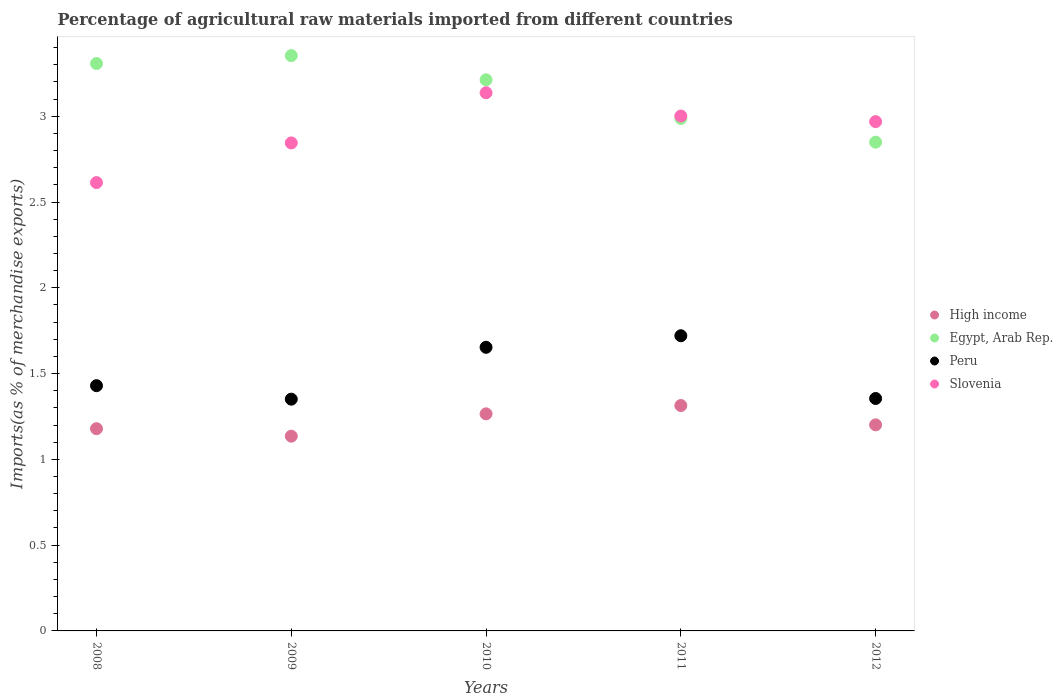What is the percentage of imports to different countries in Slovenia in 2009?
Give a very brief answer. 2.84. Across all years, what is the maximum percentage of imports to different countries in Peru?
Provide a short and direct response. 1.72. Across all years, what is the minimum percentage of imports to different countries in Slovenia?
Make the answer very short. 2.61. In which year was the percentage of imports to different countries in Peru maximum?
Make the answer very short. 2011. In which year was the percentage of imports to different countries in High income minimum?
Ensure brevity in your answer.  2009. What is the total percentage of imports to different countries in High income in the graph?
Offer a very short reply. 6.09. What is the difference between the percentage of imports to different countries in Slovenia in 2009 and that in 2012?
Your answer should be very brief. -0.12. What is the difference between the percentage of imports to different countries in Slovenia in 2009 and the percentage of imports to different countries in Egypt, Arab Rep. in 2010?
Your answer should be very brief. -0.37. What is the average percentage of imports to different countries in Slovenia per year?
Make the answer very short. 2.91. In the year 2010, what is the difference between the percentage of imports to different countries in Slovenia and percentage of imports to different countries in Egypt, Arab Rep.?
Ensure brevity in your answer.  -0.08. In how many years, is the percentage of imports to different countries in Egypt, Arab Rep. greater than 2.4 %?
Keep it short and to the point. 5. What is the ratio of the percentage of imports to different countries in Egypt, Arab Rep. in 2009 to that in 2011?
Provide a short and direct response. 1.12. Is the difference between the percentage of imports to different countries in Slovenia in 2008 and 2009 greater than the difference between the percentage of imports to different countries in Egypt, Arab Rep. in 2008 and 2009?
Your response must be concise. No. What is the difference between the highest and the second highest percentage of imports to different countries in High income?
Your answer should be compact. 0.05. What is the difference between the highest and the lowest percentage of imports to different countries in Egypt, Arab Rep.?
Ensure brevity in your answer.  0.5. In how many years, is the percentage of imports to different countries in Egypt, Arab Rep. greater than the average percentage of imports to different countries in Egypt, Arab Rep. taken over all years?
Keep it short and to the point. 3. Is it the case that in every year, the sum of the percentage of imports to different countries in High income and percentage of imports to different countries in Peru  is greater than the sum of percentage of imports to different countries in Slovenia and percentage of imports to different countries in Egypt, Arab Rep.?
Your answer should be compact. No. Is the percentage of imports to different countries in Slovenia strictly less than the percentage of imports to different countries in Peru over the years?
Your answer should be very brief. No. How many dotlines are there?
Offer a very short reply. 4. How many years are there in the graph?
Make the answer very short. 5. What is the difference between two consecutive major ticks on the Y-axis?
Give a very brief answer. 0.5. Are the values on the major ticks of Y-axis written in scientific E-notation?
Give a very brief answer. No. Does the graph contain grids?
Offer a terse response. No. Where does the legend appear in the graph?
Offer a terse response. Center right. How are the legend labels stacked?
Offer a very short reply. Vertical. What is the title of the graph?
Provide a succinct answer. Percentage of agricultural raw materials imported from different countries. Does "Morocco" appear as one of the legend labels in the graph?
Offer a very short reply. No. What is the label or title of the Y-axis?
Your response must be concise. Imports(as % of merchandise exports). What is the Imports(as % of merchandise exports) of High income in 2008?
Your answer should be compact. 1.18. What is the Imports(as % of merchandise exports) in Egypt, Arab Rep. in 2008?
Offer a terse response. 3.31. What is the Imports(as % of merchandise exports) of Peru in 2008?
Give a very brief answer. 1.43. What is the Imports(as % of merchandise exports) in Slovenia in 2008?
Keep it short and to the point. 2.61. What is the Imports(as % of merchandise exports) in High income in 2009?
Offer a terse response. 1.14. What is the Imports(as % of merchandise exports) in Egypt, Arab Rep. in 2009?
Ensure brevity in your answer.  3.35. What is the Imports(as % of merchandise exports) of Peru in 2009?
Your response must be concise. 1.35. What is the Imports(as % of merchandise exports) in Slovenia in 2009?
Your response must be concise. 2.84. What is the Imports(as % of merchandise exports) in High income in 2010?
Provide a succinct answer. 1.27. What is the Imports(as % of merchandise exports) in Egypt, Arab Rep. in 2010?
Provide a succinct answer. 3.21. What is the Imports(as % of merchandise exports) in Peru in 2010?
Ensure brevity in your answer.  1.65. What is the Imports(as % of merchandise exports) of Slovenia in 2010?
Keep it short and to the point. 3.14. What is the Imports(as % of merchandise exports) in High income in 2011?
Give a very brief answer. 1.31. What is the Imports(as % of merchandise exports) in Egypt, Arab Rep. in 2011?
Your answer should be very brief. 2.99. What is the Imports(as % of merchandise exports) of Peru in 2011?
Offer a very short reply. 1.72. What is the Imports(as % of merchandise exports) of Slovenia in 2011?
Give a very brief answer. 3. What is the Imports(as % of merchandise exports) in High income in 2012?
Provide a succinct answer. 1.2. What is the Imports(as % of merchandise exports) in Egypt, Arab Rep. in 2012?
Ensure brevity in your answer.  2.85. What is the Imports(as % of merchandise exports) of Peru in 2012?
Offer a very short reply. 1.35. What is the Imports(as % of merchandise exports) of Slovenia in 2012?
Offer a very short reply. 2.97. Across all years, what is the maximum Imports(as % of merchandise exports) in High income?
Ensure brevity in your answer.  1.31. Across all years, what is the maximum Imports(as % of merchandise exports) of Egypt, Arab Rep.?
Make the answer very short. 3.35. Across all years, what is the maximum Imports(as % of merchandise exports) in Peru?
Make the answer very short. 1.72. Across all years, what is the maximum Imports(as % of merchandise exports) in Slovenia?
Your answer should be very brief. 3.14. Across all years, what is the minimum Imports(as % of merchandise exports) in High income?
Ensure brevity in your answer.  1.14. Across all years, what is the minimum Imports(as % of merchandise exports) of Egypt, Arab Rep.?
Ensure brevity in your answer.  2.85. Across all years, what is the minimum Imports(as % of merchandise exports) in Peru?
Your answer should be very brief. 1.35. Across all years, what is the minimum Imports(as % of merchandise exports) of Slovenia?
Offer a very short reply. 2.61. What is the total Imports(as % of merchandise exports) of High income in the graph?
Offer a terse response. 6.09. What is the total Imports(as % of merchandise exports) of Egypt, Arab Rep. in the graph?
Your answer should be compact. 15.71. What is the total Imports(as % of merchandise exports) in Peru in the graph?
Give a very brief answer. 7.51. What is the total Imports(as % of merchandise exports) of Slovenia in the graph?
Your answer should be very brief. 14.57. What is the difference between the Imports(as % of merchandise exports) in High income in 2008 and that in 2009?
Offer a terse response. 0.04. What is the difference between the Imports(as % of merchandise exports) in Egypt, Arab Rep. in 2008 and that in 2009?
Your answer should be compact. -0.05. What is the difference between the Imports(as % of merchandise exports) of Peru in 2008 and that in 2009?
Your answer should be very brief. 0.08. What is the difference between the Imports(as % of merchandise exports) of Slovenia in 2008 and that in 2009?
Your answer should be compact. -0.23. What is the difference between the Imports(as % of merchandise exports) in High income in 2008 and that in 2010?
Ensure brevity in your answer.  -0.09. What is the difference between the Imports(as % of merchandise exports) in Egypt, Arab Rep. in 2008 and that in 2010?
Your answer should be compact. 0.09. What is the difference between the Imports(as % of merchandise exports) in Peru in 2008 and that in 2010?
Keep it short and to the point. -0.22. What is the difference between the Imports(as % of merchandise exports) of Slovenia in 2008 and that in 2010?
Make the answer very short. -0.52. What is the difference between the Imports(as % of merchandise exports) of High income in 2008 and that in 2011?
Give a very brief answer. -0.14. What is the difference between the Imports(as % of merchandise exports) in Egypt, Arab Rep. in 2008 and that in 2011?
Keep it short and to the point. 0.32. What is the difference between the Imports(as % of merchandise exports) of Peru in 2008 and that in 2011?
Provide a short and direct response. -0.29. What is the difference between the Imports(as % of merchandise exports) in Slovenia in 2008 and that in 2011?
Provide a short and direct response. -0.39. What is the difference between the Imports(as % of merchandise exports) in High income in 2008 and that in 2012?
Offer a terse response. -0.02. What is the difference between the Imports(as % of merchandise exports) of Egypt, Arab Rep. in 2008 and that in 2012?
Make the answer very short. 0.46. What is the difference between the Imports(as % of merchandise exports) of Peru in 2008 and that in 2012?
Make the answer very short. 0.07. What is the difference between the Imports(as % of merchandise exports) in Slovenia in 2008 and that in 2012?
Provide a short and direct response. -0.36. What is the difference between the Imports(as % of merchandise exports) in High income in 2009 and that in 2010?
Your answer should be compact. -0.13. What is the difference between the Imports(as % of merchandise exports) of Egypt, Arab Rep. in 2009 and that in 2010?
Make the answer very short. 0.14. What is the difference between the Imports(as % of merchandise exports) in Peru in 2009 and that in 2010?
Make the answer very short. -0.3. What is the difference between the Imports(as % of merchandise exports) in Slovenia in 2009 and that in 2010?
Give a very brief answer. -0.29. What is the difference between the Imports(as % of merchandise exports) of High income in 2009 and that in 2011?
Offer a terse response. -0.18. What is the difference between the Imports(as % of merchandise exports) in Egypt, Arab Rep. in 2009 and that in 2011?
Your answer should be very brief. 0.37. What is the difference between the Imports(as % of merchandise exports) in Peru in 2009 and that in 2011?
Provide a short and direct response. -0.37. What is the difference between the Imports(as % of merchandise exports) of Slovenia in 2009 and that in 2011?
Keep it short and to the point. -0.16. What is the difference between the Imports(as % of merchandise exports) in High income in 2009 and that in 2012?
Your response must be concise. -0.07. What is the difference between the Imports(as % of merchandise exports) of Egypt, Arab Rep. in 2009 and that in 2012?
Make the answer very short. 0.5. What is the difference between the Imports(as % of merchandise exports) in Peru in 2009 and that in 2012?
Your response must be concise. -0. What is the difference between the Imports(as % of merchandise exports) in Slovenia in 2009 and that in 2012?
Keep it short and to the point. -0.12. What is the difference between the Imports(as % of merchandise exports) in High income in 2010 and that in 2011?
Give a very brief answer. -0.05. What is the difference between the Imports(as % of merchandise exports) in Egypt, Arab Rep. in 2010 and that in 2011?
Make the answer very short. 0.23. What is the difference between the Imports(as % of merchandise exports) in Peru in 2010 and that in 2011?
Offer a very short reply. -0.07. What is the difference between the Imports(as % of merchandise exports) of Slovenia in 2010 and that in 2011?
Make the answer very short. 0.14. What is the difference between the Imports(as % of merchandise exports) of High income in 2010 and that in 2012?
Provide a succinct answer. 0.06. What is the difference between the Imports(as % of merchandise exports) in Egypt, Arab Rep. in 2010 and that in 2012?
Your response must be concise. 0.36. What is the difference between the Imports(as % of merchandise exports) in Peru in 2010 and that in 2012?
Your response must be concise. 0.3. What is the difference between the Imports(as % of merchandise exports) of Slovenia in 2010 and that in 2012?
Keep it short and to the point. 0.17. What is the difference between the Imports(as % of merchandise exports) in High income in 2011 and that in 2012?
Provide a succinct answer. 0.11. What is the difference between the Imports(as % of merchandise exports) in Egypt, Arab Rep. in 2011 and that in 2012?
Give a very brief answer. 0.14. What is the difference between the Imports(as % of merchandise exports) in Peru in 2011 and that in 2012?
Provide a short and direct response. 0.37. What is the difference between the Imports(as % of merchandise exports) in Slovenia in 2011 and that in 2012?
Offer a very short reply. 0.03. What is the difference between the Imports(as % of merchandise exports) of High income in 2008 and the Imports(as % of merchandise exports) of Egypt, Arab Rep. in 2009?
Provide a succinct answer. -2.17. What is the difference between the Imports(as % of merchandise exports) of High income in 2008 and the Imports(as % of merchandise exports) of Peru in 2009?
Your response must be concise. -0.17. What is the difference between the Imports(as % of merchandise exports) in High income in 2008 and the Imports(as % of merchandise exports) in Slovenia in 2009?
Offer a terse response. -1.67. What is the difference between the Imports(as % of merchandise exports) of Egypt, Arab Rep. in 2008 and the Imports(as % of merchandise exports) of Peru in 2009?
Ensure brevity in your answer.  1.96. What is the difference between the Imports(as % of merchandise exports) in Egypt, Arab Rep. in 2008 and the Imports(as % of merchandise exports) in Slovenia in 2009?
Your answer should be compact. 0.46. What is the difference between the Imports(as % of merchandise exports) of Peru in 2008 and the Imports(as % of merchandise exports) of Slovenia in 2009?
Offer a very short reply. -1.42. What is the difference between the Imports(as % of merchandise exports) in High income in 2008 and the Imports(as % of merchandise exports) in Egypt, Arab Rep. in 2010?
Provide a short and direct response. -2.03. What is the difference between the Imports(as % of merchandise exports) in High income in 2008 and the Imports(as % of merchandise exports) in Peru in 2010?
Keep it short and to the point. -0.47. What is the difference between the Imports(as % of merchandise exports) in High income in 2008 and the Imports(as % of merchandise exports) in Slovenia in 2010?
Ensure brevity in your answer.  -1.96. What is the difference between the Imports(as % of merchandise exports) in Egypt, Arab Rep. in 2008 and the Imports(as % of merchandise exports) in Peru in 2010?
Provide a short and direct response. 1.65. What is the difference between the Imports(as % of merchandise exports) of Egypt, Arab Rep. in 2008 and the Imports(as % of merchandise exports) of Slovenia in 2010?
Ensure brevity in your answer.  0.17. What is the difference between the Imports(as % of merchandise exports) of Peru in 2008 and the Imports(as % of merchandise exports) of Slovenia in 2010?
Your response must be concise. -1.71. What is the difference between the Imports(as % of merchandise exports) in High income in 2008 and the Imports(as % of merchandise exports) in Egypt, Arab Rep. in 2011?
Offer a very short reply. -1.81. What is the difference between the Imports(as % of merchandise exports) of High income in 2008 and the Imports(as % of merchandise exports) of Peru in 2011?
Provide a short and direct response. -0.54. What is the difference between the Imports(as % of merchandise exports) of High income in 2008 and the Imports(as % of merchandise exports) of Slovenia in 2011?
Your response must be concise. -1.82. What is the difference between the Imports(as % of merchandise exports) of Egypt, Arab Rep. in 2008 and the Imports(as % of merchandise exports) of Peru in 2011?
Your answer should be compact. 1.59. What is the difference between the Imports(as % of merchandise exports) of Egypt, Arab Rep. in 2008 and the Imports(as % of merchandise exports) of Slovenia in 2011?
Provide a succinct answer. 0.31. What is the difference between the Imports(as % of merchandise exports) of Peru in 2008 and the Imports(as % of merchandise exports) of Slovenia in 2011?
Keep it short and to the point. -1.57. What is the difference between the Imports(as % of merchandise exports) in High income in 2008 and the Imports(as % of merchandise exports) in Egypt, Arab Rep. in 2012?
Make the answer very short. -1.67. What is the difference between the Imports(as % of merchandise exports) in High income in 2008 and the Imports(as % of merchandise exports) in Peru in 2012?
Ensure brevity in your answer.  -0.18. What is the difference between the Imports(as % of merchandise exports) of High income in 2008 and the Imports(as % of merchandise exports) of Slovenia in 2012?
Provide a short and direct response. -1.79. What is the difference between the Imports(as % of merchandise exports) of Egypt, Arab Rep. in 2008 and the Imports(as % of merchandise exports) of Peru in 2012?
Your answer should be very brief. 1.95. What is the difference between the Imports(as % of merchandise exports) in Egypt, Arab Rep. in 2008 and the Imports(as % of merchandise exports) in Slovenia in 2012?
Your response must be concise. 0.34. What is the difference between the Imports(as % of merchandise exports) of Peru in 2008 and the Imports(as % of merchandise exports) of Slovenia in 2012?
Keep it short and to the point. -1.54. What is the difference between the Imports(as % of merchandise exports) of High income in 2009 and the Imports(as % of merchandise exports) of Egypt, Arab Rep. in 2010?
Offer a very short reply. -2.08. What is the difference between the Imports(as % of merchandise exports) in High income in 2009 and the Imports(as % of merchandise exports) in Peru in 2010?
Ensure brevity in your answer.  -0.52. What is the difference between the Imports(as % of merchandise exports) of High income in 2009 and the Imports(as % of merchandise exports) of Slovenia in 2010?
Give a very brief answer. -2. What is the difference between the Imports(as % of merchandise exports) in Egypt, Arab Rep. in 2009 and the Imports(as % of merchandise exports) in Peru in 2010?
Your response must be concise. 1.7. What is the difference between the Imports(as % of merchandise exports) in Egypt, Arab Rep. in 2009 and the Imports(as % of merchandise exports) in Slovenia in 2010?
Ensure brevity in your answer.  0.22. What is the difference between the Imports(as % of merchandise exports) of Peru in 2009 and the Imports(as % of merchandise exports) of Slovenia in 2010?
Give a very brief answer. -1.79. What is the difference between the Imports(as % of merchandise exports) of High income in 2009 and the Imports(as % of merchandise exports) of Egypt, Arab Rep. in 2011?
Offer a very short reply. -1.85. What is the difference between the Imports(as % of merchandise exports) of High income in 2009 and the Imports(as % of merchandise exports) of Peru in 2011?
Keep it short and to the point. -0.59. What is the difference between the Imports(as % of merchandise exports) in High income in 2009 and the Imports(as % of merchandise exports) in Slovenia in 2011?
Your response must be concise. -1.87. What is the difference between the Imports(as % of merchandise exports) in Egypt, Arab Rep. in 2009 and the Imports(as % of merchandise exports) in Peru in 2011?
Keep it short and to the point. 1.63. What is the difference between the Imports(as % of merchandise exports) of Egypt, Arab Rep. in 2009 and the Imports(as % of merchandise exports) of Slovenia in 2011?
Keep it short and to the point. 0.35. What is the difference between the Imports(as % of merchandise exports) in Peru in 2009 and the Imports(as % of merchandise exports) in Slovenia in 2011?
Provide a short and direct response. -1.65. What is the difference between the Imports(as % of merchandise exports) of High income in 2009 and the Imports(as % of merchandise exports) of Egypt, Arab Rep. in 2012?
Ensure brevity in your answer.  -1.71. What is the difference between the Imports(as % of merchandise exports) in High income in 2009 and the Imports(as % of merchandise exports) in Peru in 2012?
Your answer should be compact. -0.22. What is the difference between the Imports(as % of merchandise exports) of High income in 2009 and the Imports(as % of merchandise exports) of Slovenia in 2012?
Offer a terse response. -1.83. What is the difference between the Imports(as % of merchandise exports) in Egypt, Arab Rep. in 2009 and the Imports(as % of merchandise exports) in Peru in 2012?
Give a very brief answer. 2. What is the difference between the Imports(as % of merchandise exports) of Egypt, Arab Rep. in 2009 and the Imports(as % of merchandise exports) of Slovenia in 2012?
Provide a short and direct response. 0.38. What is the difference between the Imports(as % of merchandise exports) of Peru in 2009 and the Imports(as % of merchandise exports) of Slovenia in 2012?
Provide a succinct answer. -1.62. What is the difference between the Imports(as % of merchandise exports) in High income in 2010 and the Imports(as % of merchandise exports) in Egypt, Arab Rep. in 2011?
Provide a succinct answer. -1.72. What is the difference between the Imports(as % of merchandise exports) of High income in 2010 and the Imports(as % of merchandise exports) of Peru in 2011?
Offer a very short reply. -0.46. What is the difference between the Imports(as % of merchandise exports) in High income in 2010 and the Imports(as % of merchandise exports) in Slovenia in 2011?
Offer a terse response. -1.74. What is the difference between the Imports(as % of merchandise exports) of Egypt, Arab Rep. in 2010 and the Imports(as % of merchandise exports) of Peru in 2011?
Make the answer very short. 1.49. What is the difference between the Imports(as % of merchandise exports) in Egypt, Arab Rep. in 2010 and the Imports(as % of merchandise exports) in Slovenia in 2011?
Offer a very short reply. 0.21. What is the difference between the Imports(as % of merchandise exports) of Peru in 2010 and the Imports(as % of merchandise exports) of Slovenia in 2011?
Ensure brevity in your answer.  -1.35. What is the difference between the Imports(as % of merchandise exports) of High income in 2010 and the Imports(as % of merchandise exports) of Egypt, Arab Rep. in 2012?
Your answer should be compact. -1.58. What is the difference between the Imports(as % of merchandise exports) of High income in 2010 and the Imports(as % of merchandise exports) of Peru in 2012?
Your answer should be very brief. -0.09. What is the difference between the Imports(as % of merchandise exports) in High income in 2010 and the Imports(as % of merchandise exports) in Slovenia in 2012?
Offer a very short reply. -1.7. What is the difference between the Imports(as % of merchandise exports) in Egypt, Arab Rep. in 2010 and the Imports(as % of merchandise exports) in Peru in 2012?
Keep it short and to the point. 1.86. What is the difference between the Imports(as % of merchandise exports) in Egypt, Arab Rep. in 2010 and the Imports(as % of merchandise exports) in Slovenia in 2012?
Your response must be concise. 0.24. What is the difference between the Imports(as % of merchandise exports) in Peru in 2010 and the Imports(as % of merchandise exports) in Slovenia in 2012?
Offer a terse response. -1.32. What is the difference between the Imports(as % of merchandise exports) of High income in 2011 and the Imports(as % of merchandise exports) of Egypt, Arab Rep. in 2012?
Offer a terse response. -1.54. What is the difference between the Imports(as % of merchandise exports) in High income in 2011 and the Imports(as % of merchandise exports) in Peru in 2012?
Provide a short and direct response. -0.04. What is the difference between the Imports(as % of merchandise exports) of High income in 2011 and the Imports(as % of merchandise exports) of Slovenia in 2012?
Offer a terse response. -1.65. What is the difference between the Imports(as % of merchandise exports) in Egypt, Arab Rep. in 2011 and the Imports(as % of merchandise exports) in Peru in 2012?
Ensure brevity in your answer.  1.63. What is the difference between the Imports(as % of merchandise exports) of Egypt, Arab Rep. in 2011 and the Imports(as % of merchandise exports) of Slovenia in 2012?
Your response must be concise. 0.02. What is the difference between the Imports(as % of merchandise exports) of Peru in 2011 and the Imports(as % of merchandise exports) of Slovenia in 2012?
Provide a short and direct response. -1.25. What is the average Imports(as % of merchandise exports) in High income per year?
Offer a terse response. 1.22. What is the average Imports(as % of merchandise exports) of Egypt, Arab Rep. per year?
Your answer should be compact. 3.14. What is the average Imports(as % of merchandise exports) in Peru per year?
Give a very brief answer. 1.5. What is the average Imports(as % of merchandise exports) of Slovenia per year?
Provide a short and direct response. 2.91. In the year 2008, what is the difference between the Imports(as % of merchandise exports) of High income and Imports(as % of merchandise exports) of Egypt, Arab Rep.?
Give a very brief answer. -2.13. In the year 2008, what is the difference between the Imports(as % of merchandise exports) in High income and Imports(as % of merchandise exports) in Peru?
Give a very brief answer. -0.25. In the year 2008, what is the difference between the Imports(as % of merchandise exports) in High income and Imports(as % of merchandise exports) in Slovenia?
Your answer should be compact. -1.43. In the year 2008, what is the difference between the Imports(as % of merchandise exports) in Egypt, Arab Rep. and Imports(as % of merchandise exports) in Peru?
Offer a very short reply. 1.88. In the year 2008, what is the difference between the Imports(as % of merchandise exports) in Egypt, Arab Rep. and Imports(as % of merchandise exports) in Slovenia?
Offer a terse response. 0.69. In the year 2008, what is the difference between the Imports(as % of merchandise exports) in Peru and Imports(as % of merchandise exports) in Slovenia?
Provide a succinct answer. -1.18. In the year 2009, what is the difference between the Imports(as % of merchandise exports) in High income and Imports(as % of merchandise exports) in Egypt, Arab Rep.?
Give a very brief answer. -2.22. In the year 2009, what is the difference between the Imports(as % of merchandise exports) in High income and Imports(as % of merchandise exports) in Peru?
Offer a terse response. -0.22. In the year 2009, what is the difference between the Imports(as % of merchandise exports) of High income and Imports(as % of merchandise exports) of Slovenia?
Provide a succinct answer. -1.71. In the year 2009, what is the difference between the Imports(as % of merchandise exports) of Egypt, Arab Rep. and Imports(as % of merchandise exports) of Peru?
Your answer should be very brief. 2. In the year 2009, what is the difference between the Imports(as % of merchandise exports) in Egypt, Arab Rep. and Imports(as % of merchandise exports) in Slovenia?
Give a very brief answer. 0.51. In the year 2009, what is the difference between the Imports(as % of merchandise exports) of Peru and Imports(as % of merchandise exports) of Slovenia?
Provide a succinct answer. -1.49. In the year 2010, what is the difference between the Imports(as % of merchandise exports) in High income and Imports(as % of merchandise exports) in Egypt, Arab Rep.?
Provide a short and direct response. -1.95. In the year 2010, what is the difference between the Imports(as % of merchandise exports) in High income and Imports(as % of merchandise exports) in Peru?
Your answer should be very brief. -0.39. In the year 2010, what is the difference between the Imports(as % of merchandise exports) of High income and Imports(as % of merchandise exports) of Slovenia?
Offer a terse response. -1.87. In the year 2010, what is the difference between the Imports(as % of merchandise exports) of Egypt, Arab Rep. and Imports(as % of merchandise exports) of Peru?
Offer a terse response. 1.56. In the year 2010, what is the difference between the Imports(as % of merchandise exports) of Egypt, Arab Rep. and Imports(as % of merchandise exports) of Slovenia?
Make the answer very short. 0.08. In the year 2010, what is the difference between the Imports(as % of merchandise exports) of Peru and Imports(as % of merchandise exports) of Slovenia?
Keep it short and to the point. -1.48. In the year 2011, what is the difference between the Imports(as % of merchandise exports) in High income and Imports(as % of merchandise exports) in Egypt, Arab Rep.?
Provide a succinct answer. -1.67. In the year 2011, what is the difference between the Imports(as % of merchandise exports) of High income and Imports(as % of merchandise exports) of Peru?
Ensure brevity in your answer.  -0.41. In the year 2011, what is the difference between the Imports(as % of merchandise exports) of High income and Imports(as % of merchandise exports) of Slovenia?
Provide a short and direct response. -1.69. In the year 2011, what is the difference between the Imports(as % of merchandise exports) of Egypt, Arab Rep. and Imports(as % of merchandise exports) of Peru?
Keep it short and to the point. 1.27. In the year 2011, what is the difference between the Imports(as % of merchandise exports) of Egypt, Arab Rep. and Imports(as % of merchandise exports) of Slovenia?
Keep it short and to the point. -0.01. In the year 2011, what is the difference between the Imports(as % of merchandise exports) in Peru and Imports(as % of merchandise exports) in Slovenia?
Provide a succinct answer. -1.28. In the year 2012, what is the difference between the Imports(as % of merchandise exports) of High income and Imports(as % of merchandise exports) of Egypt, Arab Rep.?
Offer a terse response. -1.65. In the year 2012, what is the difference between the Imports(as % of merchandise exports) in High income and Imports(as % of merchandise exports) in Peru?
Provide a short and direct response. -0.15. In the year 2012, what is the difference between the Imports(as % of merchandise exports) of High income and Imports(as % of merchandise exports) of Slovenia?
Keep it short and to the point. -1.77. In the year 2012, what is the difference between the Imports(as % of merchandise exports) of Egypt, Arab Rep. and Imports(as % of merchandise exports) of Peru?
Make the answer very short. 1.49. In the year 2012, what is the difference between the Imports(as % of merchandise exports) of Egypt, Arab Rep. and Imports(as % of merchandise exports) of Slovenia?
Provide a succinct answer. -0.12. In the year 2012, what is the difference between the Imports(as % of merchandise exports) in Peru and Imports(as % of merchandise exports) in Slovenia?
Keep it short and to the point. -1.61. What is the ratio of the Imports(as % of merchandise exports) in High income in 2008 to that in 2009?
Your answer should be very brief. 1.04. What is the ratio of the Imports(as % of merchandise exports) of Egypt, Arab Rep. in 2008 to that in 2009?
Your response must be concise. 0.99. What is the ratio of the Imports(as % of merchandise exports) in Peru in 2008 to that in 2009?
Ensure brevity in your answer.  1.06. What is the ratio of the Imports(as % of merchandise exports) in Slovenia in 2008 to that in 2009?
Offer a terse response. 0.92. What is the ratio of the Imports(as % of merchandise exports) of High income in 2008 to that in 2010?
Keep it short and to the point. 0.93. What is the ratio of the Imports(as % of merchandise exports) of Egypt, Arab Rep. in 2008 to that in 2010?
Offer a very short reply. 1.03. What is the ratio of the Imports(as % of merchandise exports) in Peru in 2008 to that in 2010?
Give a very brief answer. 0.86. What is the ratio of the Imports(as % of merchandise exports) of Slovenia in 2008 to that in 2010?
Provide a succinct answer. 0.83. What is the ratio of the Imports(as % of merchandise exports) in High income in 2008 to that in 2011?
Offer a terse response. 0.9. What is the ratio of the Imports(as % of merchandise exports) of Egypt, Arab Rep. in 2008 to that in 2011?
Keep it short and to the point. 1.11. What is the ratio of the Imports(as % of merchandise exports) of Peru in 2008 to that in 2011?
Make the answer very short. 0.83. What is the ratio of the Imports(as % of merchandise exports) in Slovenia in 2008 to that in 2011?
Provide a succinct answer. 0.87. What is the ratio of the Imports(as % of merchandise exports) of High income in 2008 to that in 2012?
Offer a very short reply. 0.98. What is the ratio of the Imports(as % of merchandise exports) of Egypt, Arab Rep. in 2008 to that in 2012?
Give a very brief answer. 1.16. What is the ratio of the Imports(as % of merchandise exports) of Peru in 2008 to that in 2012?
Give a very brief answer. 1.06. What is the ratio of the Imports(as % of merchandise exports) in Slovenia in 2008 to that in 2012?
Offer a very short reply. 0.88. What is the ratio of the Imports(as % of merchandise exports) in High income in 2009 to that in 2010?
Offer a very short reply. 0.9. What is the ratio of the Imports(as % of merchandise exports) of Egypt, Arab Rep. in 2009 to that in 2010?
Your response must be concise. 1.04. What is the ratio of the Imports(as % of merchandise exports) of Peru in 2009 to that in 2010?
Provide a succinct answer. 0.82. What is the ratio of the Imports(as % of merchandise exports) in Slovenia in 2009 to that in 2010?
Keep it short and to the point. 0.91. What is the ratio of the Imports(as % of merchandise exports) of High income in 2009 to that in 2011?
Make the answer very short. 0.86. What is the ratio of the Imports(as % of merchandise exports) of Egypt, Arab Rep. in 2009 to that in 2011?
Provide a short and direct response. 1.12. What is the ratio of the Imports(as % of merchandise exports) in Peru in 2009 to that in 2011?
Offer a very short reply. 0.79. What is the ratio of the Imports(as % of merchandise exports) in Slovenia in 2009 to that in 2011?
Make the answer very short. 0.95. What is the ratio of the Imports(as % of merchandise exports) of High income in 2009 to that in 2012?
Make the answer very short. 0.94. What is the ratio of the Imports(as % of merchandise exports) of Egypt, Arab Rep. in 2009 to that in 2012?
Your answer should be compact. 1.18. What is the ratio of the Imports(as % of merchandise exports) in Peru in 2009 to that in 2012?
Provide a short and direct response. 1. What is the ratio of the Imports(as % of merchandise exports) of Slovenia in 2009 to that in 2012?
Provide a succinct answer. 0.96. What is the ratio of the Imports(as % of merchandise exports) in High income in 2010 to that in 2011?
Provide a succinct answer. 0.96. What is the ratio of the Imports(as % of merchandise exports) of Egypt, Arab Rep. in 2010 to that in 2011?
Your answer should be compact. 1.08. What is the ratio of the Imports(as % of merchandise exports) in Peru in 2010 to that in 2011?
Provide a short and direct response. 0.96. What is the ratio of the Imports(as % of merchandise exports) of Slovenia in 2010 to that in 2011?
Provide a succinct answer. 1.05. What is the ratio of the Imports(as % of merchandise exports) in High income in 2010 to that in 2012?
Provide a short and direct response. 1.05. What is the ratio of the Imports(as % of merchandise exports) of Egypt, Arab Rep. in 2010 to that in 2012?
Offer a terse response. 1.13. What is the ratio of the Imports(as % of merchandise exports) in Peru in 2010 to that in 2012?
Provide a short and direct response. 1.22. What is the ratio of the Imports(as % of merchandise exports) in Slovenia in 2010 to that in 2012?
Your response must be concise. 1.06. What is the ratio of the Imports(as % of merchandise exports) in High income in 2011 to that in 2012?
Give a very brief answer. 1.09. What is the ratio of the Imports(as % of merchandise exports) of Egypt, Arab Rep. in 2011 to that in 2012?
Your response must be concise. 1.05. What is the ratio of the Imports(as % of merchandise exports) in Peru in 2011 to that in 2012?
Keep it short and to the point. 1.27. What is the ratio of the Imports(as % of merchandise exports) of Slovenia in 2011 to that in 2012?
Your response must be concise. 1.01. What is the difference between the highest and the second highest Imports(as % of merchandise exports) of High income?
Your answer should be compact. 0.05. What is the difference between the highest and the second highest Imports(as % of merchandise exports) in Egypt, Arab Rep.?
Provide a short and direct response. 0.05. What is the difference between the highest and the second highest Imports(as % of merchandise exports) in Peru?
Keep it short and to the point. 0.07. What is the difference between the highest and the second highest Imports(as % of merchandise exports) of Slovenia?
Keep it short and to the point. 0.14. What is the difference between the highest and the lowest Imports(as % of merchandise exports) of High income?
Keep it short and to the point. 0.18. What is the difference between the highest and the lowest Imports(as % of merchandise exports) of Egypt, Arab Rep.?
Keep it short and to the point. 0.5. What is the difference between the highest and the lowest Imports(as % of merchandise exports) of Peru?
Give a very brief answer. 0.37. What is the difference between the highest and the lowest Imports(as % of merchandise exports) of Slovenia?
Provide a succinct answer. 0.52. 